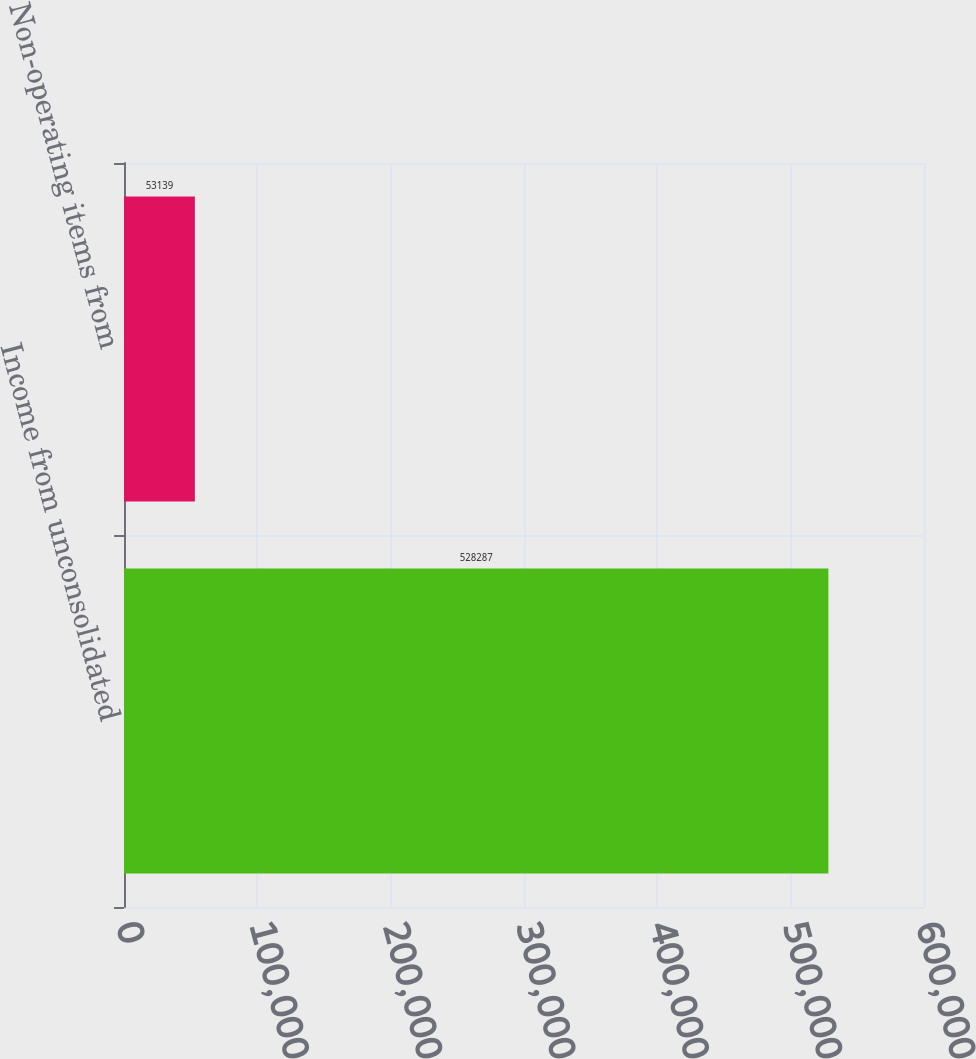<chart> <loc_0><loc_0><loc_500><loc_500><bar_chart><fcel>Income from unconsolidated<fcel>Non-operating items from<nl><fcel>528287<fcel>53139<nl></chart> 